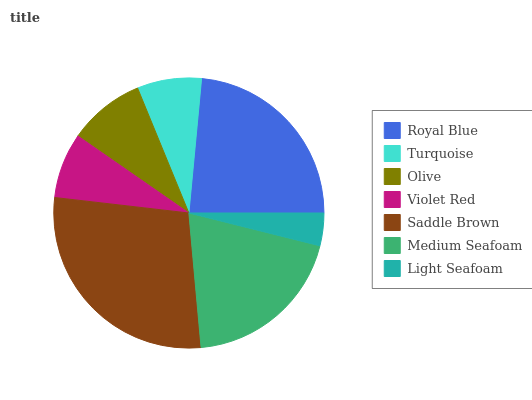Is Light Seafoam the minimum?
Answer yes or no. Yes. Is Saddle Brown the maximum?
Answer yes or no. Yes. Is Turquoise the minimum?
Answer yes or no. No. Is Turquoise the maximum?
Answer yes or no. No. Is Royal Blue greater than Turquoise?
Answer yes or no. Yes. Is Turquoise less than Royal Blue?
Answer yes or no. Yes. Is Turquoise greater than Royal Blue?
Answer yes or no. No. Is Royal Blue less than Turquoise?
Answer yes or no. No. Is Olive the high median?
Answer yes or no. Yes. Is Olive the low median?
Answer yes or no. Yes. Is Medium Seafoam the high median?
Answer yes or no. No. Is Saddle Brown the low median?
Answer yes or no. No. 